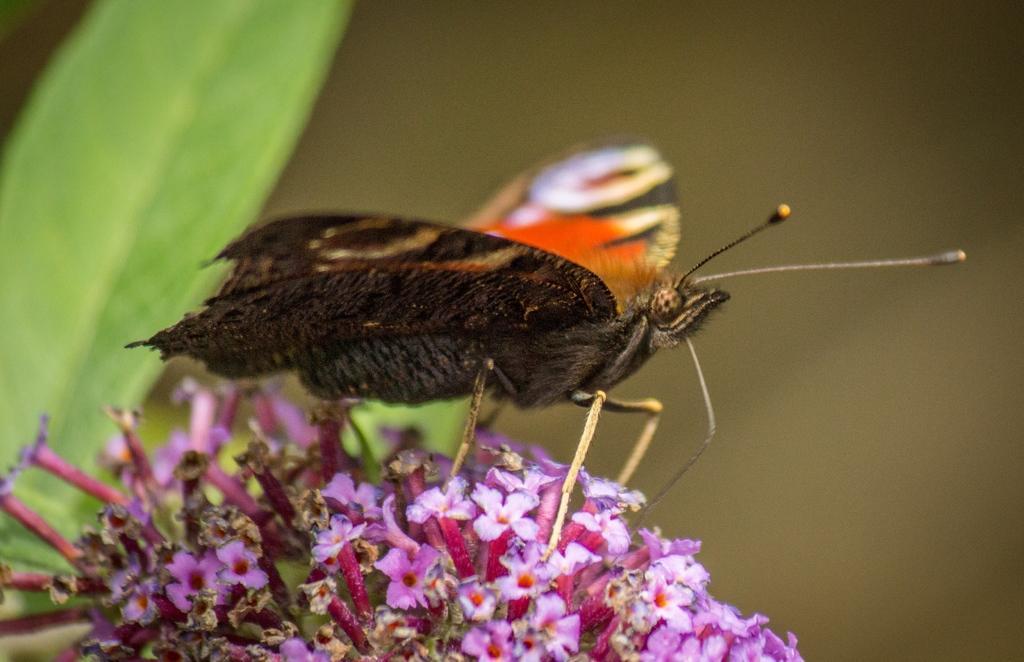Please provide a concise description of this image. In this image, we can see a butterfly on the flowers. Background there is a blur view. Here we can see leaves. 